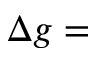Convert formula to latex. <formula><loc_0><loc_0><loc_500><loc_500>\Delta g =</formula> 